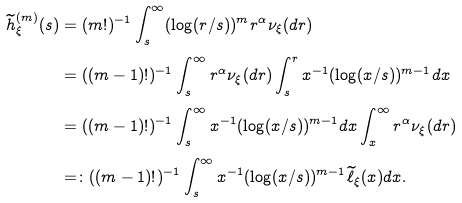<formula> <loc_0><loc_0><loc_500><loc_500>\widetilde { h } _ { \xi } ^ { ( m ) } ( s ) & = ( m ! ) ^ { - 1 } \int _ { s } ^ { \infty } ( \log ( r / s ) ) ^ { m } r ^ { \alpha } \nu _ { \xi } ( d r ) \\ & = ( { ( m - 1 ) ! } ) ^ { - 1 } \int _ { s } ^ { \infty } r ^ { \alpha } \nu _ { \xi } ( d r ) \int _ { s } ^ { r } x ^ { - 1 } ( \log ( x / s ) ) ^ { m - 1 } d x \\ & = ( { ( m - 1 ) ! } ) ^ { - 1 } \int _ { s } ^ { \infty } { x } ^ { - 1 } ( \log ( x / s ) ) ^ { m - 1 } d x \int _ { x } ^ { \infty } r ^ { \alpha } \nu _ { \xi } ( d r ) \\ & = \colon ( { ( m - 1 ) ! } ) ^ { - 1 } \int _ { s } ^ { \infty } { x } ^ { - 1 } ( \log ( x / s ) ) ^ { m - 1 } \widetilde { \ell } _ { \xi } ( x ) d x .</formula> 